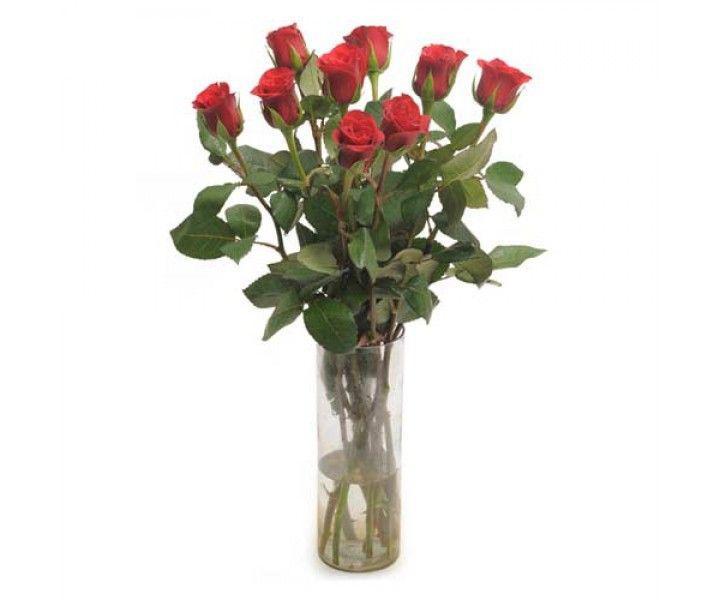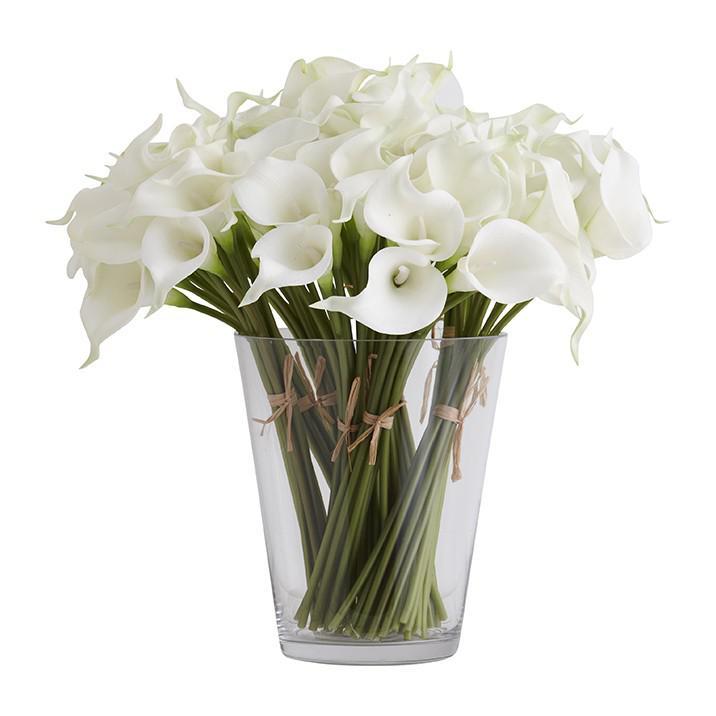The first image is the image on the left, the second image is the image on the right. Evaluate the accuracy of this statement regarding the images: "There are at least nine roses in the image on the left.". Is it true? Answer yes or no. Yes. 